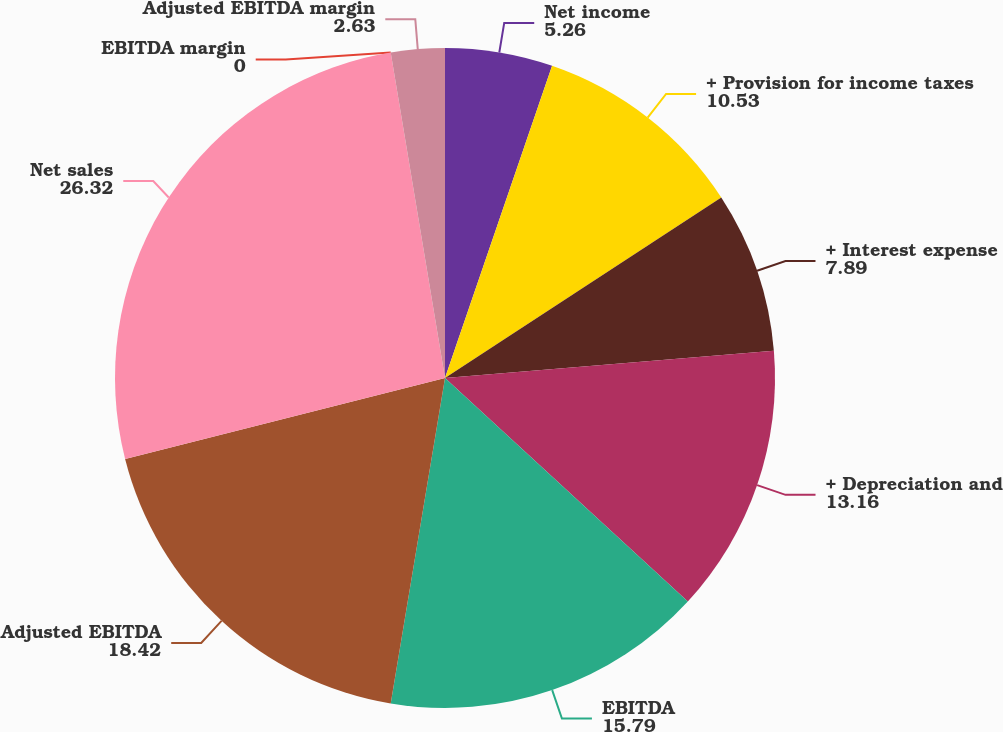<chart> <loc_0><loc_0><loc_500><loc_500><pie_chart><fcel>Net income<fcel>+ Provision for income taxes<fcel>+ Interest expense<fcel>+ Depreciation and<fcel>EBITDA<fcel>Adjusted EBITDA<fcel>Net sales<fcel>EBITDA margin<fcel>Adjusted EBITDA margin<nl><fcel>5.26%<fcel>10.53%<fcel>7.89%<fcel>13.16%<fcel>15.79%<fcel>18.42%<fcel>26.32%<fcel>0.0%<fcel>2.63%<nl></chart> 